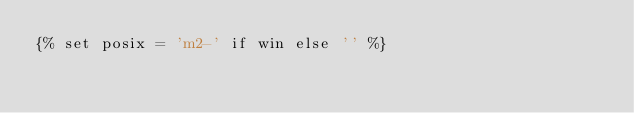Convert code to text. <code><loc_0><loc_0><loc_500><loc_500><_YAML_>{% set posix = 'm2-' if win else '' %}</code> 